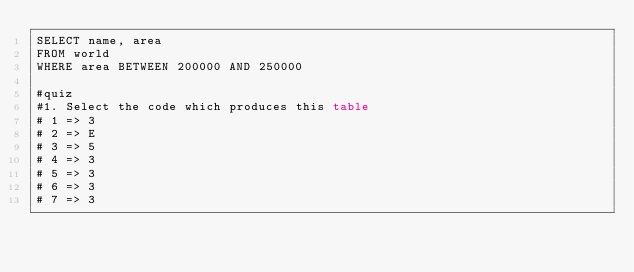Convert code to text. <code><loc_0><loc_0><loc_500><loc_500><_SQL_>SELECT name, area 
FROM world
WHERE area BETWEEN 200000 AND 250000

#quiz
#1. Select the code which produces this table
# 1 => 3
# 2 => E
# 3 => 5
# 4 => 3
# 5 => 3
# 6 => 3
# 7 => 3</code> 